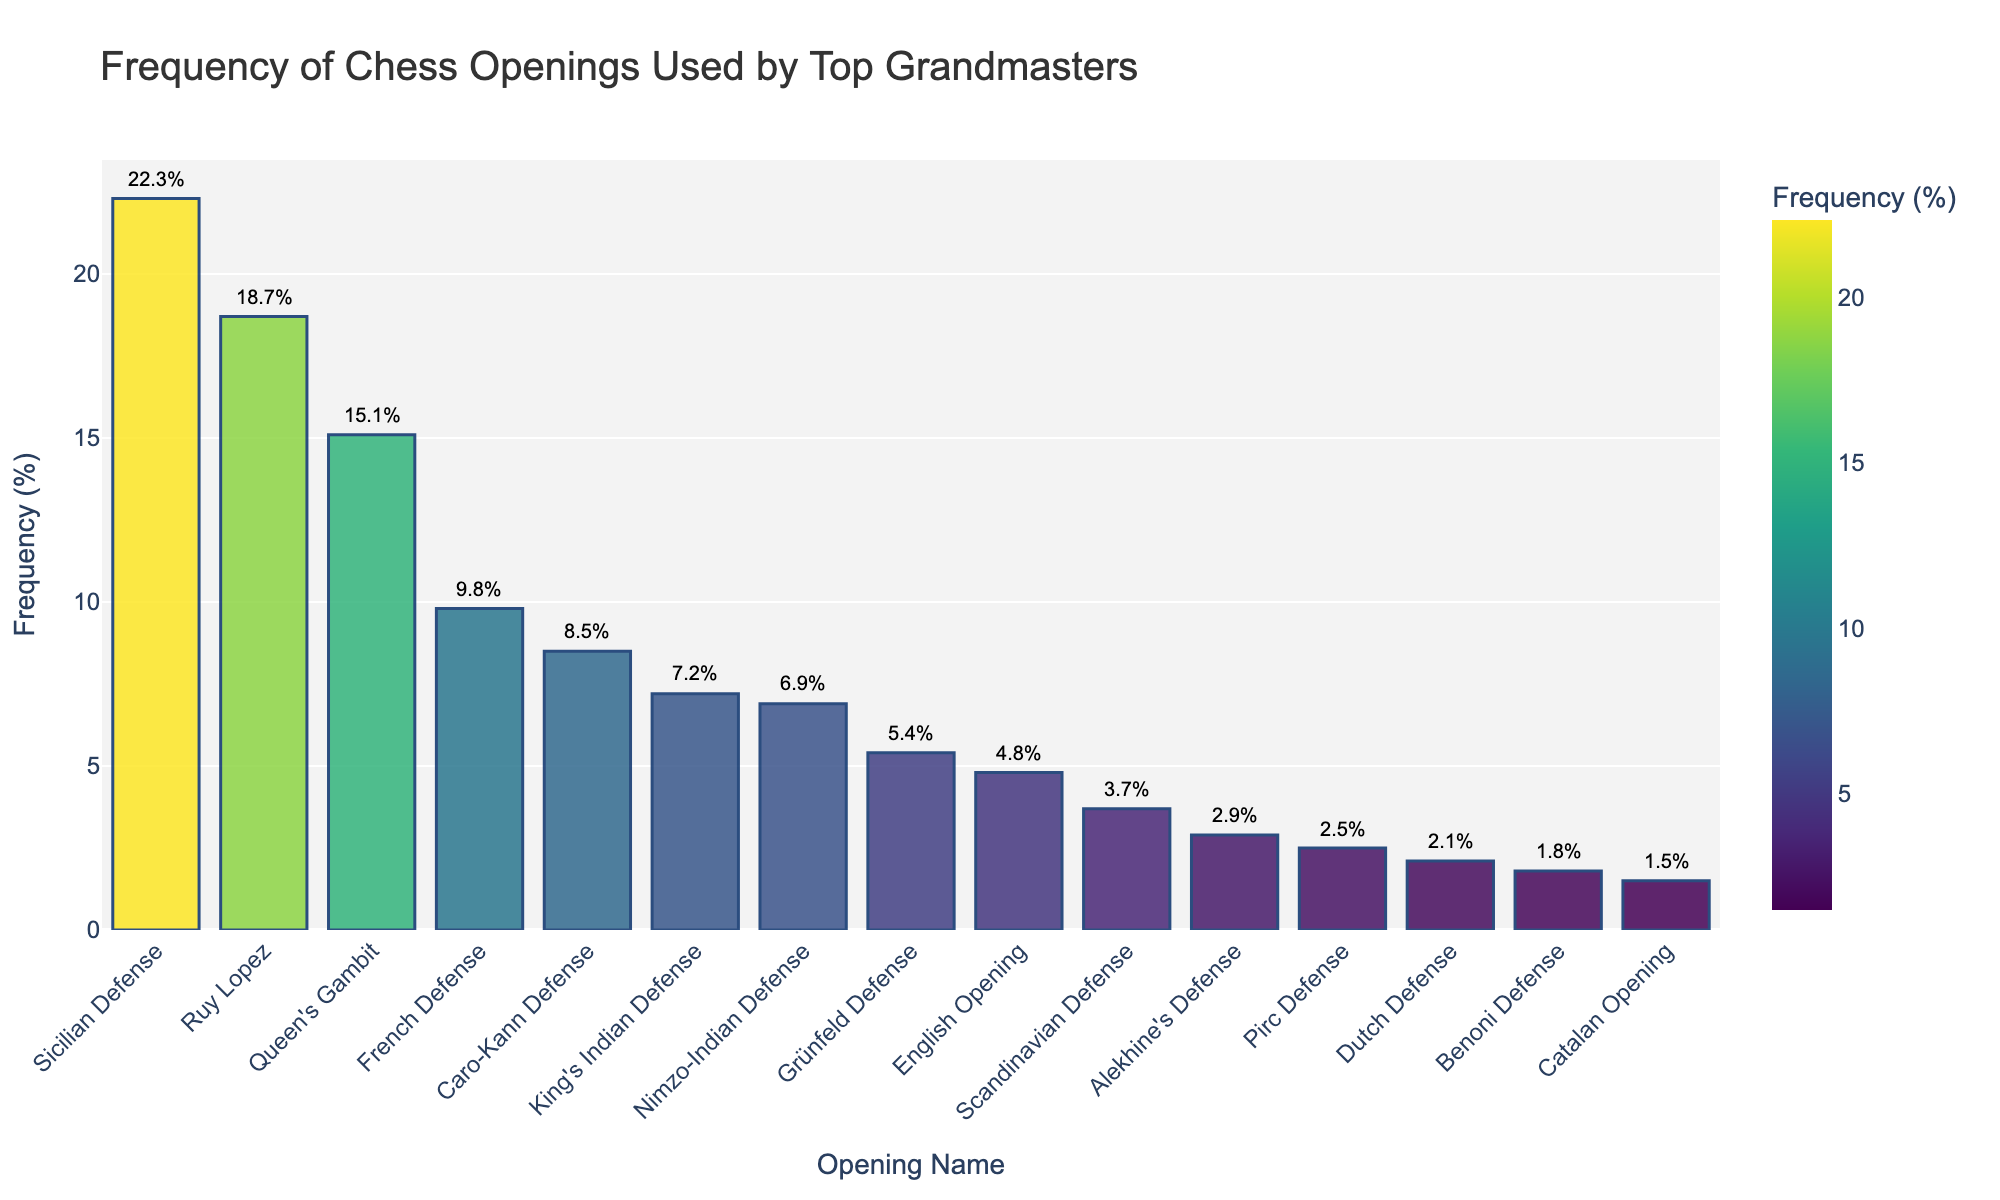What's the most frequent chess opening used by top Grandmasters? Look at the bar with the highest value. The Sicilian Defense has the highest bar representing a frequency of 22.3%.
Answer: Sicilian Defense Which opening is used more frequently, the French Defense or the English Opening? Compare the heights of the bars for the French Defense (9.8%) and the English Opening (4.8%). The French Defense bar is higher.
Answer: French Defense What is the combined frequency of the Sicilian Defense and Ruy Lopez openings? Add the frequencies of the Sicilian Defense (22.3%) and Ruy Lopez (18.7%). 22.3 + 18.7 = 41.0%
Answer: 41.0% Between the Nimzo-Indian Defense and the Pirc Defense, which has a lower frequency? Compare the bars for Nimzo-Indian Defense (6.9%) and Pirc Defense (2.5%). The Pirc Defense bar is lower.
Answer: Pirc Defense How does the frequency of the Caro-Kann Defense compare to the Queen's Gambit? Compare the heights of the bars for Caro-Kann Defense (8.5%) and Queen's Gambit (15.1%). The Caro-Kann Defense frequency is lower.
Answer: Caro-Kann Defense is lower What is the average frequency of the top three most popular openings? Identify the top three openings (Sicilian Defense 22.3%, Ruy Lopez 18.7%, Queen's Gambit 15.1%). Add their frequencies and divide by 3. (22.3 + 18.7 + 15.1) / 3 = 56.1 / 3 = 18.7%.
Answer: 18.7% Which opening has the smallest frequency, and what is the percentage? Look for the shortest bar, which corresponds to the Catalan Opening, with a frequency of 1.5%.
Answer: Catalan Opening, 1.5% By how much does the frequency of the King's Indian Defense exceed the Dutch Defense? Subtract the frequency of the Dutch Defense (2.1%) from the King's Indian Defense (7.2%). 7.2 - 2.1 = 5.1%
Answer: 5.1% What is the total frequency of all chess openings combined? Add all the frequencies given: 22.3 + 18.7 + 15.1 + 9.8 + 8.5 + 7.2 + 6.9 + 5.4 + 4.8 + 3.7 + 2.9 + 2.5 + 2.1 + 1.8 + 1.5 = 112.2%
Answer: 112.2% Are there more openings with a frequency greater than or less than 5%? Count the number of openings with a frequency > 5% and <= 5%. Openings > 5%: Sicilian Defense, Ruy Lopez, Queen's Gambit, French Defense, Caro-Kann Defense, King's Indian Defense, Nimzo-Indian Defense, Grünfeld Defense (8). Openings <= 5%: English Opening, Scandinavian Defense, Alekhine's Defense, Pirc Defense, Dutch Defense, Benoni Defense, Catalan Opening (7). So, there are more openings with frequency > 5%.
Answer: More openings with frequency > 5% 